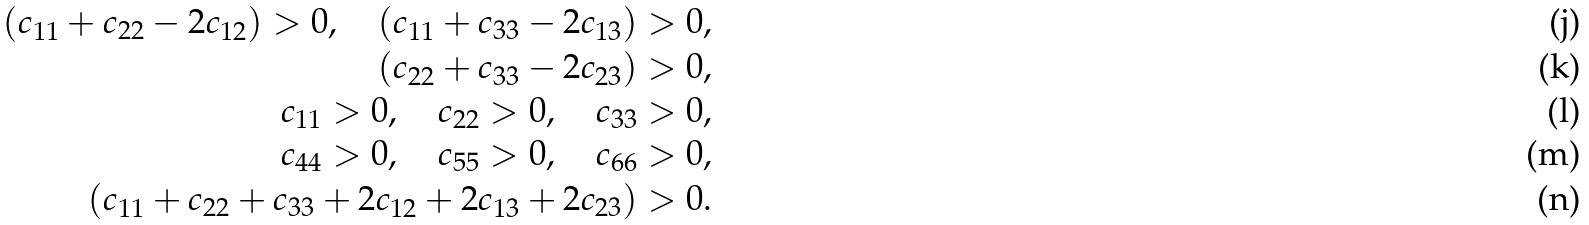Convert formula to latex. <formula><loc_0><loc_0><loc_500><loc_500>( c _ { 1 1 } + c _ { 2 2 } - 2 c _ { 1 2 } ) > 0 , \quad ( c _ { 1 1 } + c _ { 3 3 } - 2 c _ { 1 3 } ) & > 0 , \\ ( c _ { 2 2 } + c _ { 3 3 } - 2 c _ { 2 3 } ) & > 0 , \\ c _ { 1 1 } > 0 , \quad c _ { 2 2 } > 0 , \quad c _ { 3 3 } & > 0 , \\ c _ { 4 4 } > 0 , \quad c _ { 5 5 } > 0 , \quad c _ { 6 6 } & > 0 , \\ ( c _ { 1 1 } + c _ { 2 2 } + c _ { 3 3 } + 2 c _ { 1 2 } + 2 c _ { 1 3 } + 2 c _ { 2 3 } ) & > 0 .</formula> 